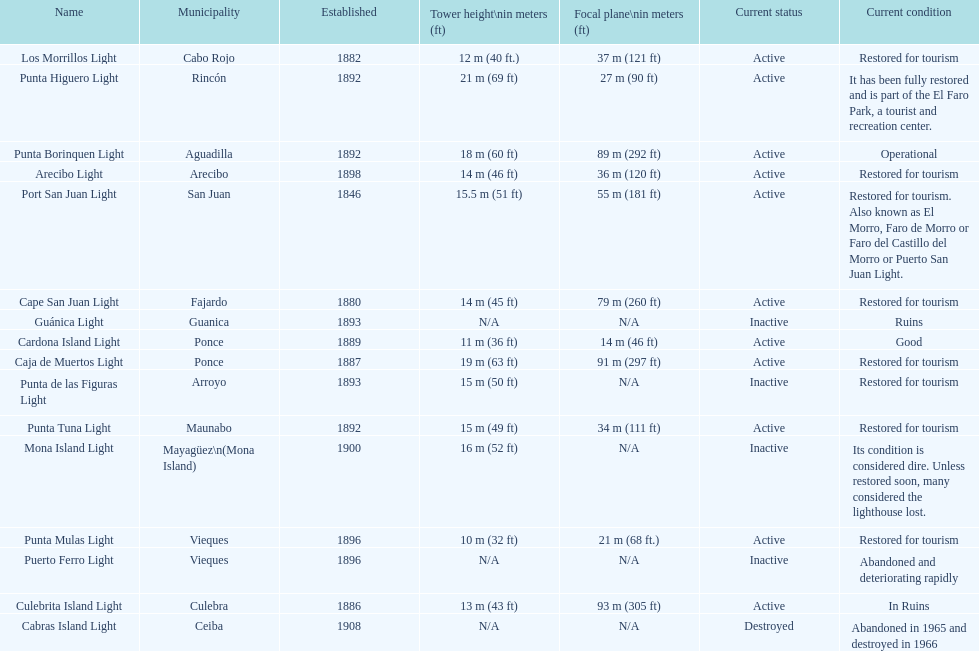How many towers are at least 18 meters tall? 3. 